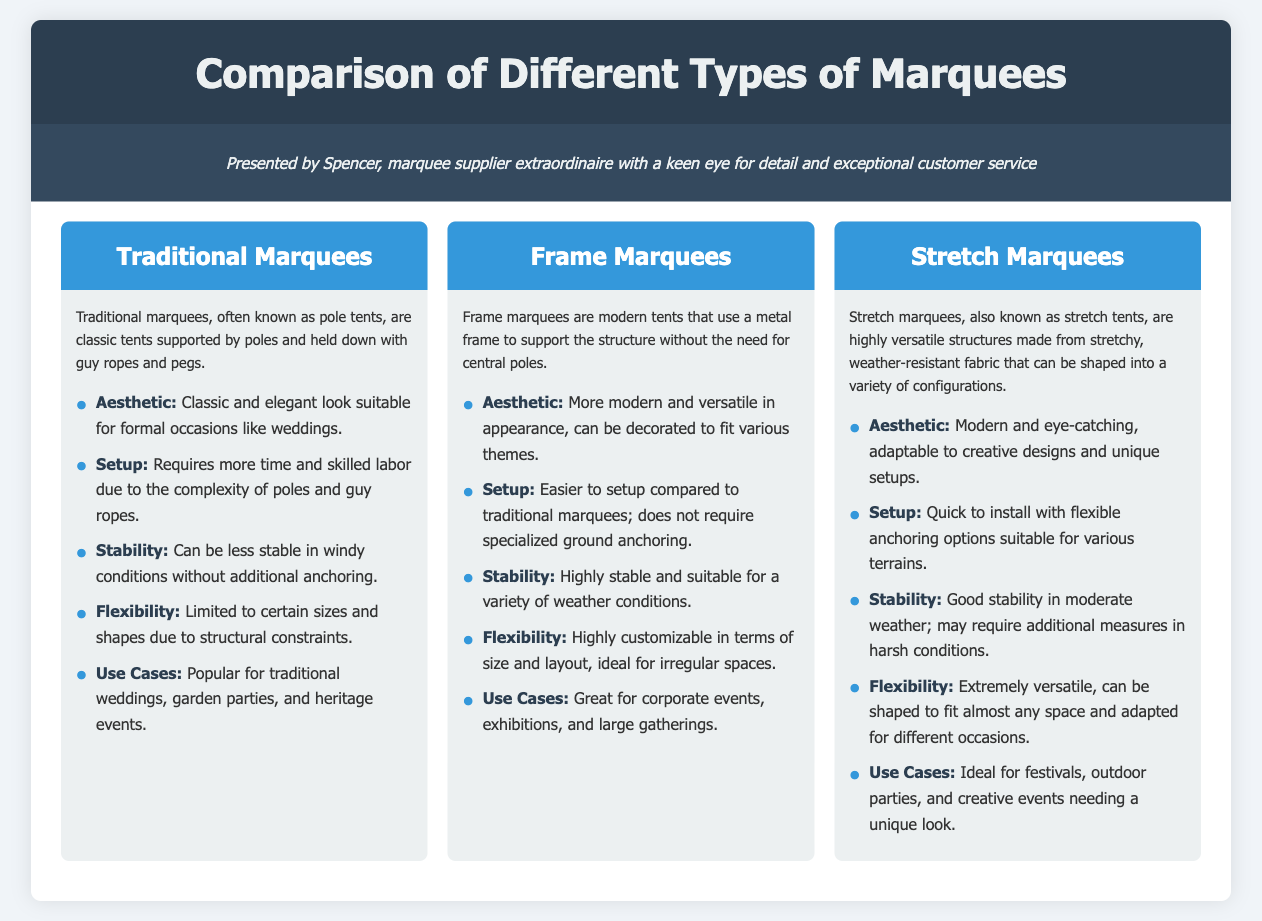What are traditional marquees also known as? Traditional marquees are often referred to as pole tents, which is explicitly mentioned in the document.
Answer: Pole tents What type of events are frame marquees great for? The document specifies that frame marquees are suitable for corporate events, exhibitions, and large gatherings.
Answer: Corporate events How flexible are stretch marquees in terms of configuration? Stretch marquees are described as extremely versatile and can be shaped to fit almost any space, indicating a high degree of flexibility.
Answer: Extremely versatile What is a key feature related to the setup of traditional marquees? The document states that setting up traditional marquees requires more time and skilled labor due to their complexity.
Answer: Requires more time and skilled labor Which type of marquee offers a modern aesthetic? Frame marquees are noted for their modern and versatile appearance, making them stand out in this category.
Answer: Frame marquees How do frame marquees compare in stability to traditional marquees? The document mentions that frame marquees are highly stable, while traditional marquees can be less stable in windy conditions.
Answer: Highly stable What is a characteristic of the stability of stretch marquees? Stretch marquees have good stability in moderate weather but may require additional measures in harsh conditions, as explained in the document.
Answer: Good stability in moderate weather What does the document say about the use cases for traditional marquees? Traditional marquees are popular for formal occasions, especially mentioned for weddings, garden parties, and heritage events.
Answer: Traditional weddings, garden parties, and heritage events 